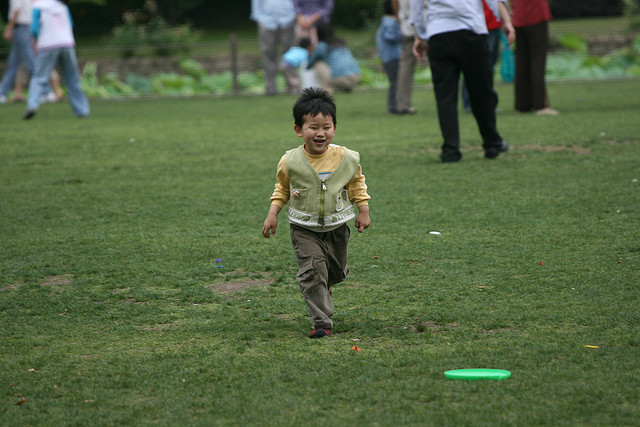How many children are there? 1 